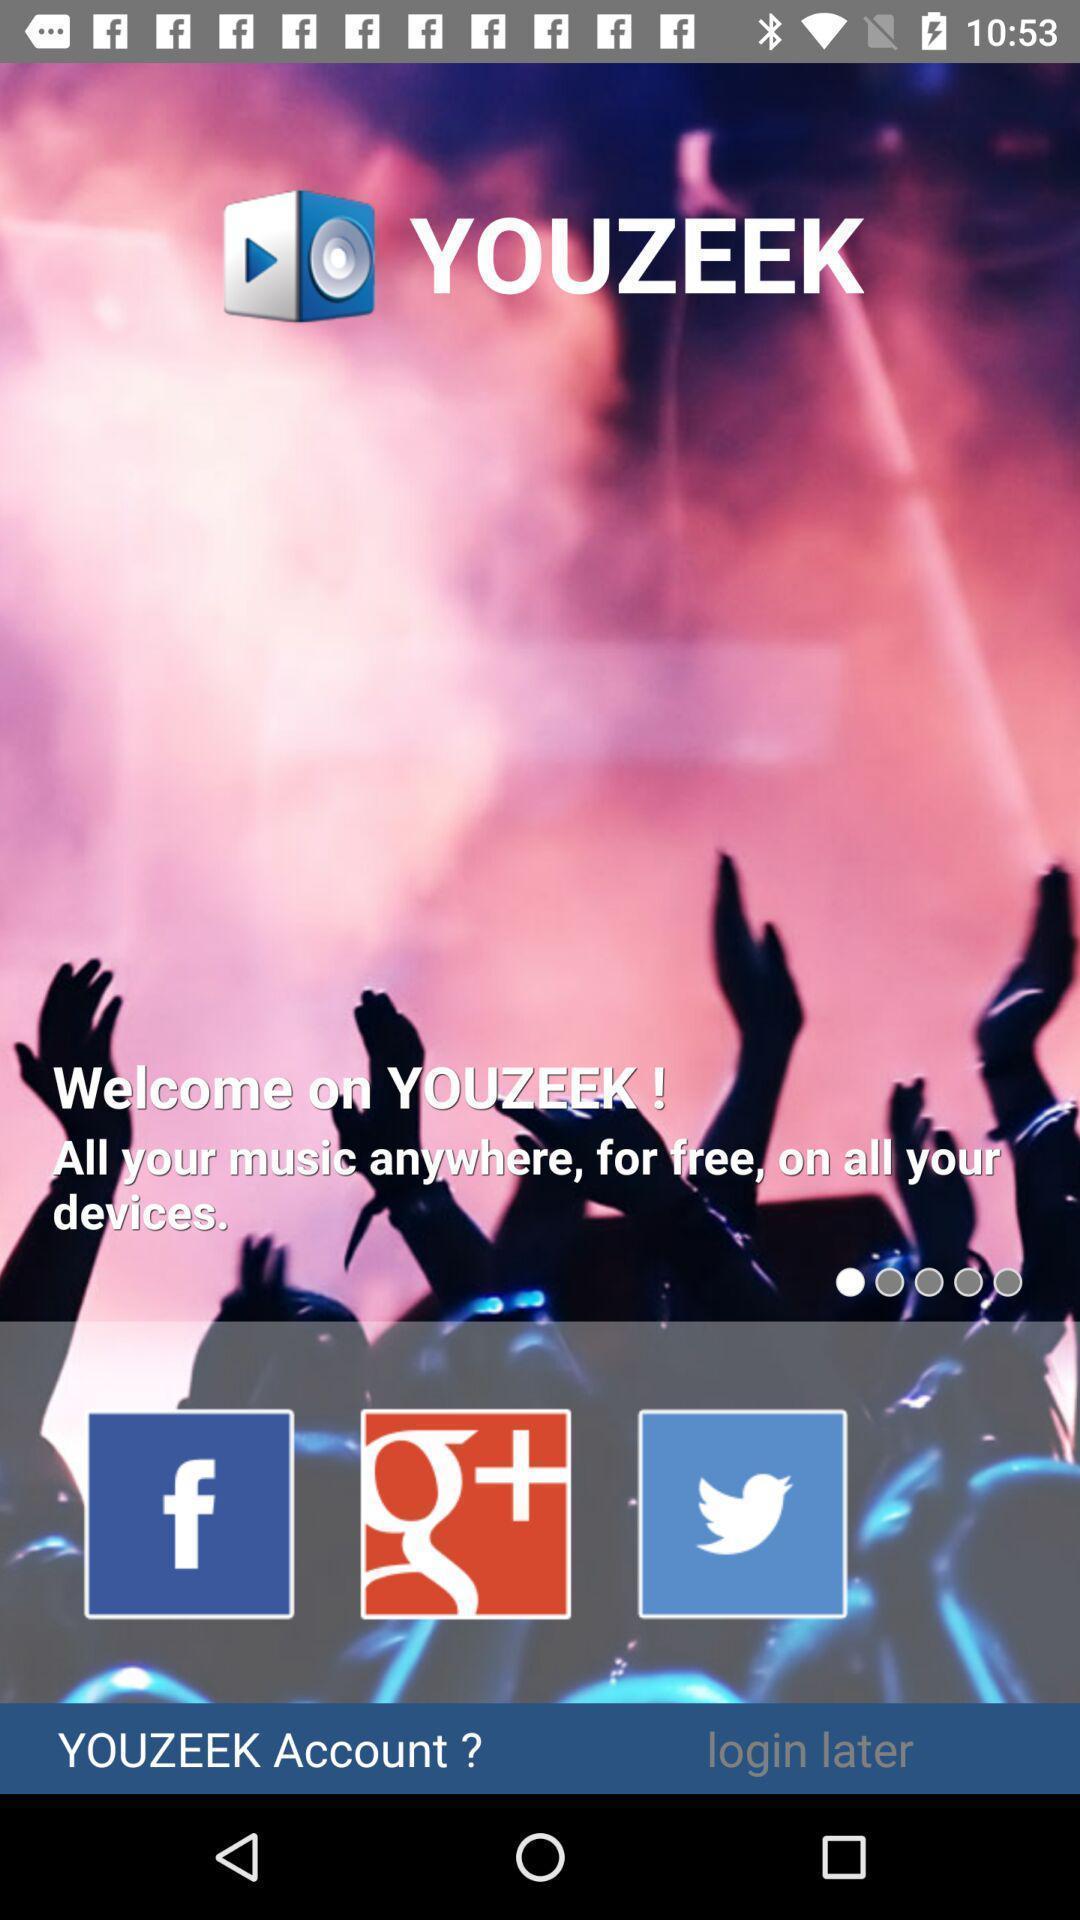Tell me what you see in this picture. Welcome page. 